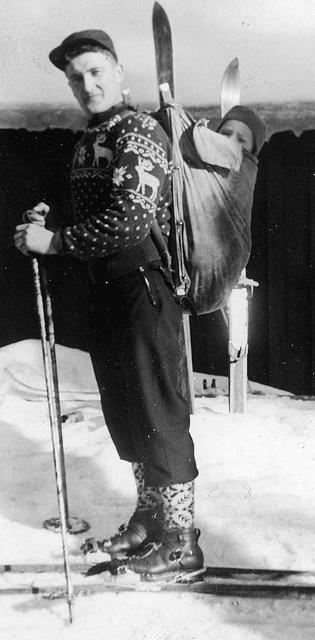What relation is the man to the boy in his backpack? Please explain your reasoning. father. The man is the boy's dad. 